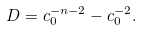Convert formula to latex. <formula><loc_0><loc_0><loc_500><loc_500>D = c _ { 0 } ^ { - n - 2 } - c _ { 0 } ^ { - 2 } .</formula> 